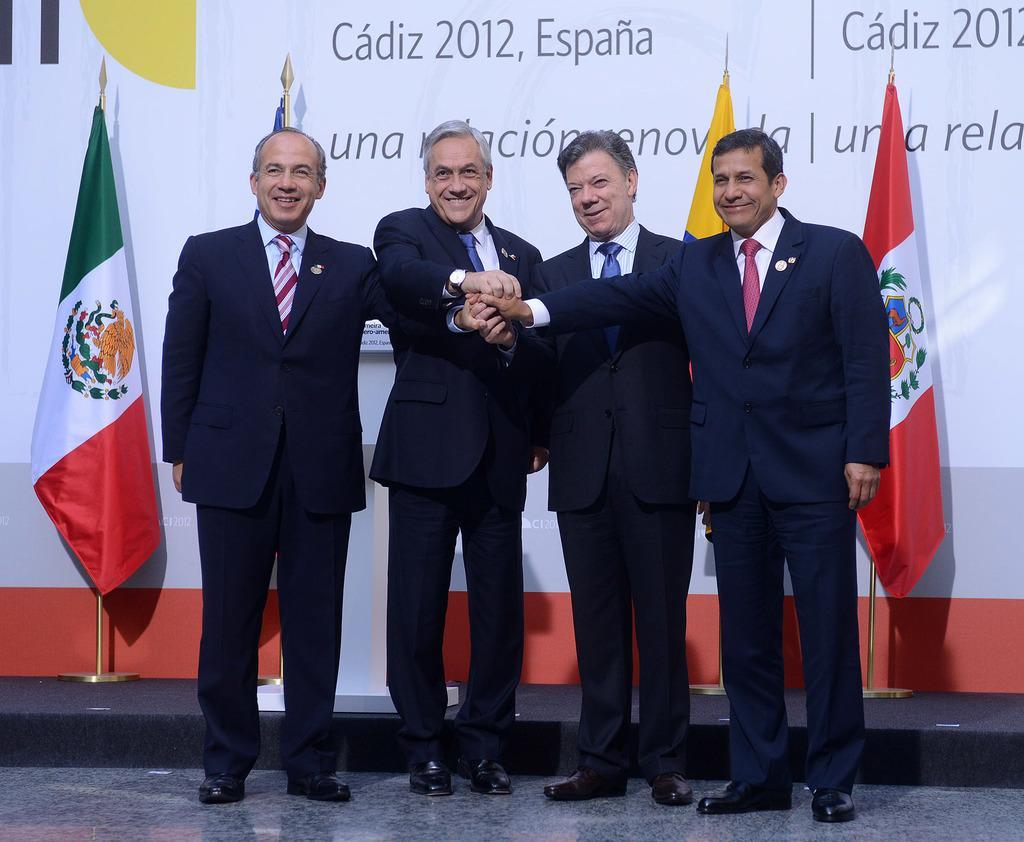In one or two sentences, can you explain what this image depicts? In this image there are four men standing. They are wearing suits. They all are smiling. Behind them there is a podium. In the background there is a banner. There is text on the banner. In front of the banner there are flags. 